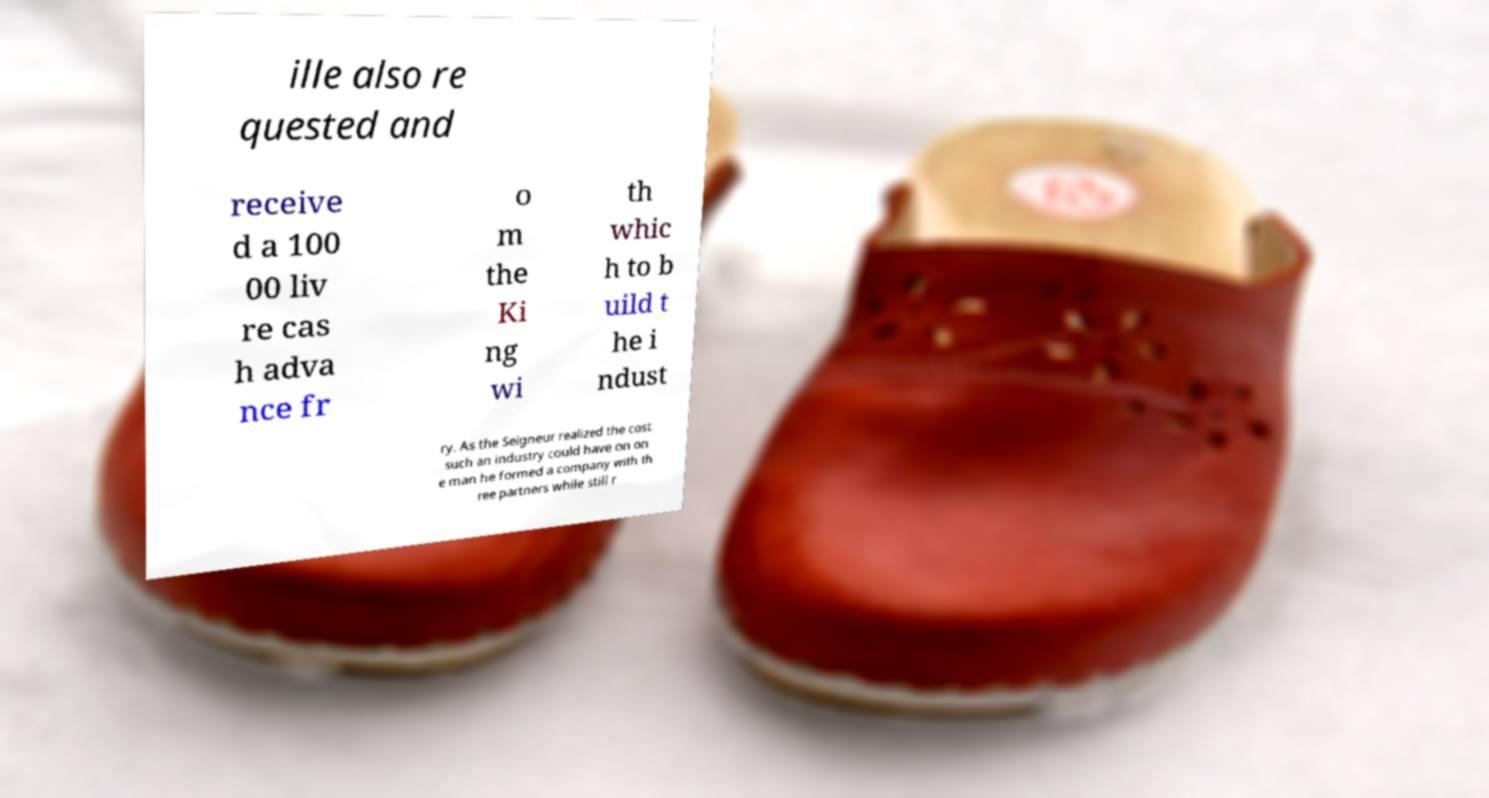Could you extract and type out the text from this image? ille also re quested and receive d a 100 00 liv re cas h adva nce fr o m the Ki ng wi th whic h to b uild t he i ndust ry. As the Seigneur realized the cost such an industry could have on on e man he formed a company with th ree partners while still r 